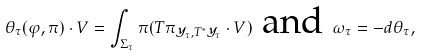Convert formula to latex. <formula><loc_0><loc_0><loc_500><loc_500>\theta _ { \tau } ( \varphi , \pi ) \cdot V = \int _ { \Sigma _ { \tau } } \pi ( T \pi _ { { \mathcal { Y } } _ { \tau } , T ^ { * } { \mathcal { Y } } _ { \tau } } \cdot V ) \text { and } \omega _ { \tau } = - d \theta _ { \tau } ,</formula> 